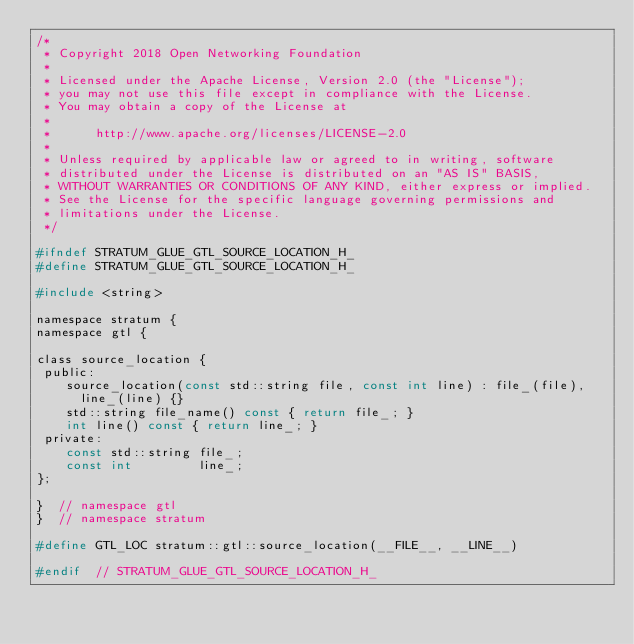Convert code to text. <code><loc_0><loc_0><loc_500><loc_500><_C_>/*
 * Copyright 2018 Open Networking Foundation
 *
 * Licensed under the Apache License, Version 2.0 (the "License");
 * you may not use this file except in compliance with the License.
 * You may obtain a copy of the License at
 *
 *      http://www.apache.org/licenses/LICENSE-2.0
 *
 * Unless required by applicable law or agreed to in writing, software
 * distributed under the License is distributed on an "AS IS" BASIS,
 * WITHOUT WARRANTIES OR CONDITIONS OF ANY KIND, either express or implied.
 * See the License for the specific language governing permissions and
 * limitations under the License.
 */

#ifndef STRATUM_GLUE_GTL_SOURCE_LOCATION_H_
#define STRATUM_GLUE_GTL_SOURCE_LOCATION_H_

#include <string>

namespace stratum {
namespace gtl {

class source_location {
 public:
    source_location(const std::string file, const int line) : file_(file),
      line_(line) {}
    std::string file_name() const { return file_; }
    int line() const { return line_; }
 private:
    const std::string file_;
    const int         line_;
};

}  // namespace gtl
}  // namespace stratum

#define GTL_LOC stratum::gtl::source_location(__FILE__, __LINE__)

#endif  // STRATUM_GLUE_GTL_SOURCE_LOCATION_H_
</code> 